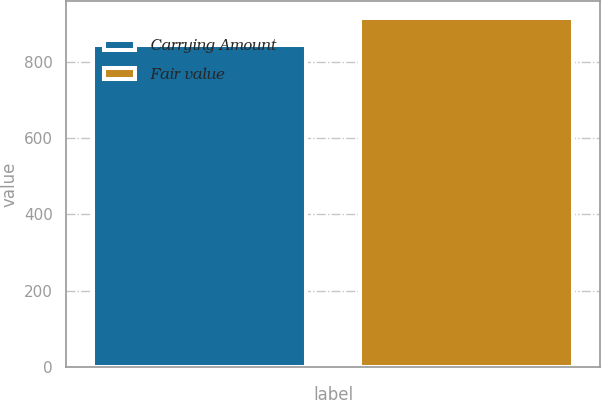Convert chart to OTSL. <chart><loc_0><loc_0><loc_500><loc_500><bar_chart><fcel>Carrying Amount<fcel>Fair value<nl><fcel>844<fcel>915<nl></chart> 